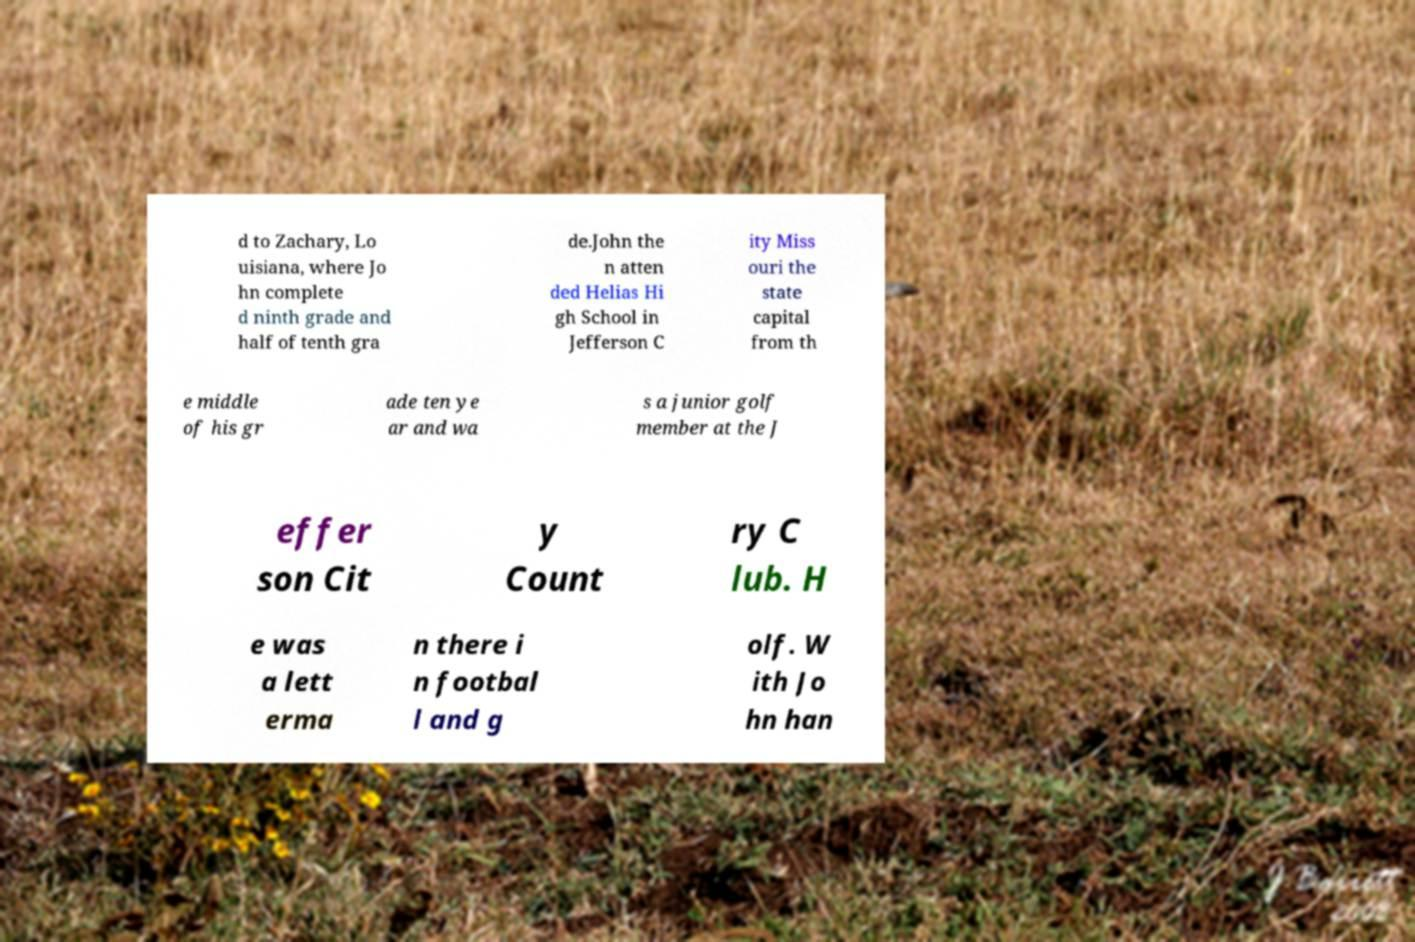Can you read and provide the text displayed in the image?This photo seems to have some interesting text. Can you extract and type it out for me? d to Zachary, Lo uisiana, where Jo hn complete d ninth grade and half of tenth gra de.John the n atten ded Helias Hi gh School in Jefferson C ity Miss ouri the state capital from th e middle of his gr ade ten ye ar and wa s a junior golf member at the J effer son Cit y Count ry C lub. H e was a lett erma n there i n footbal l and g olf. W ith Jo hn han 